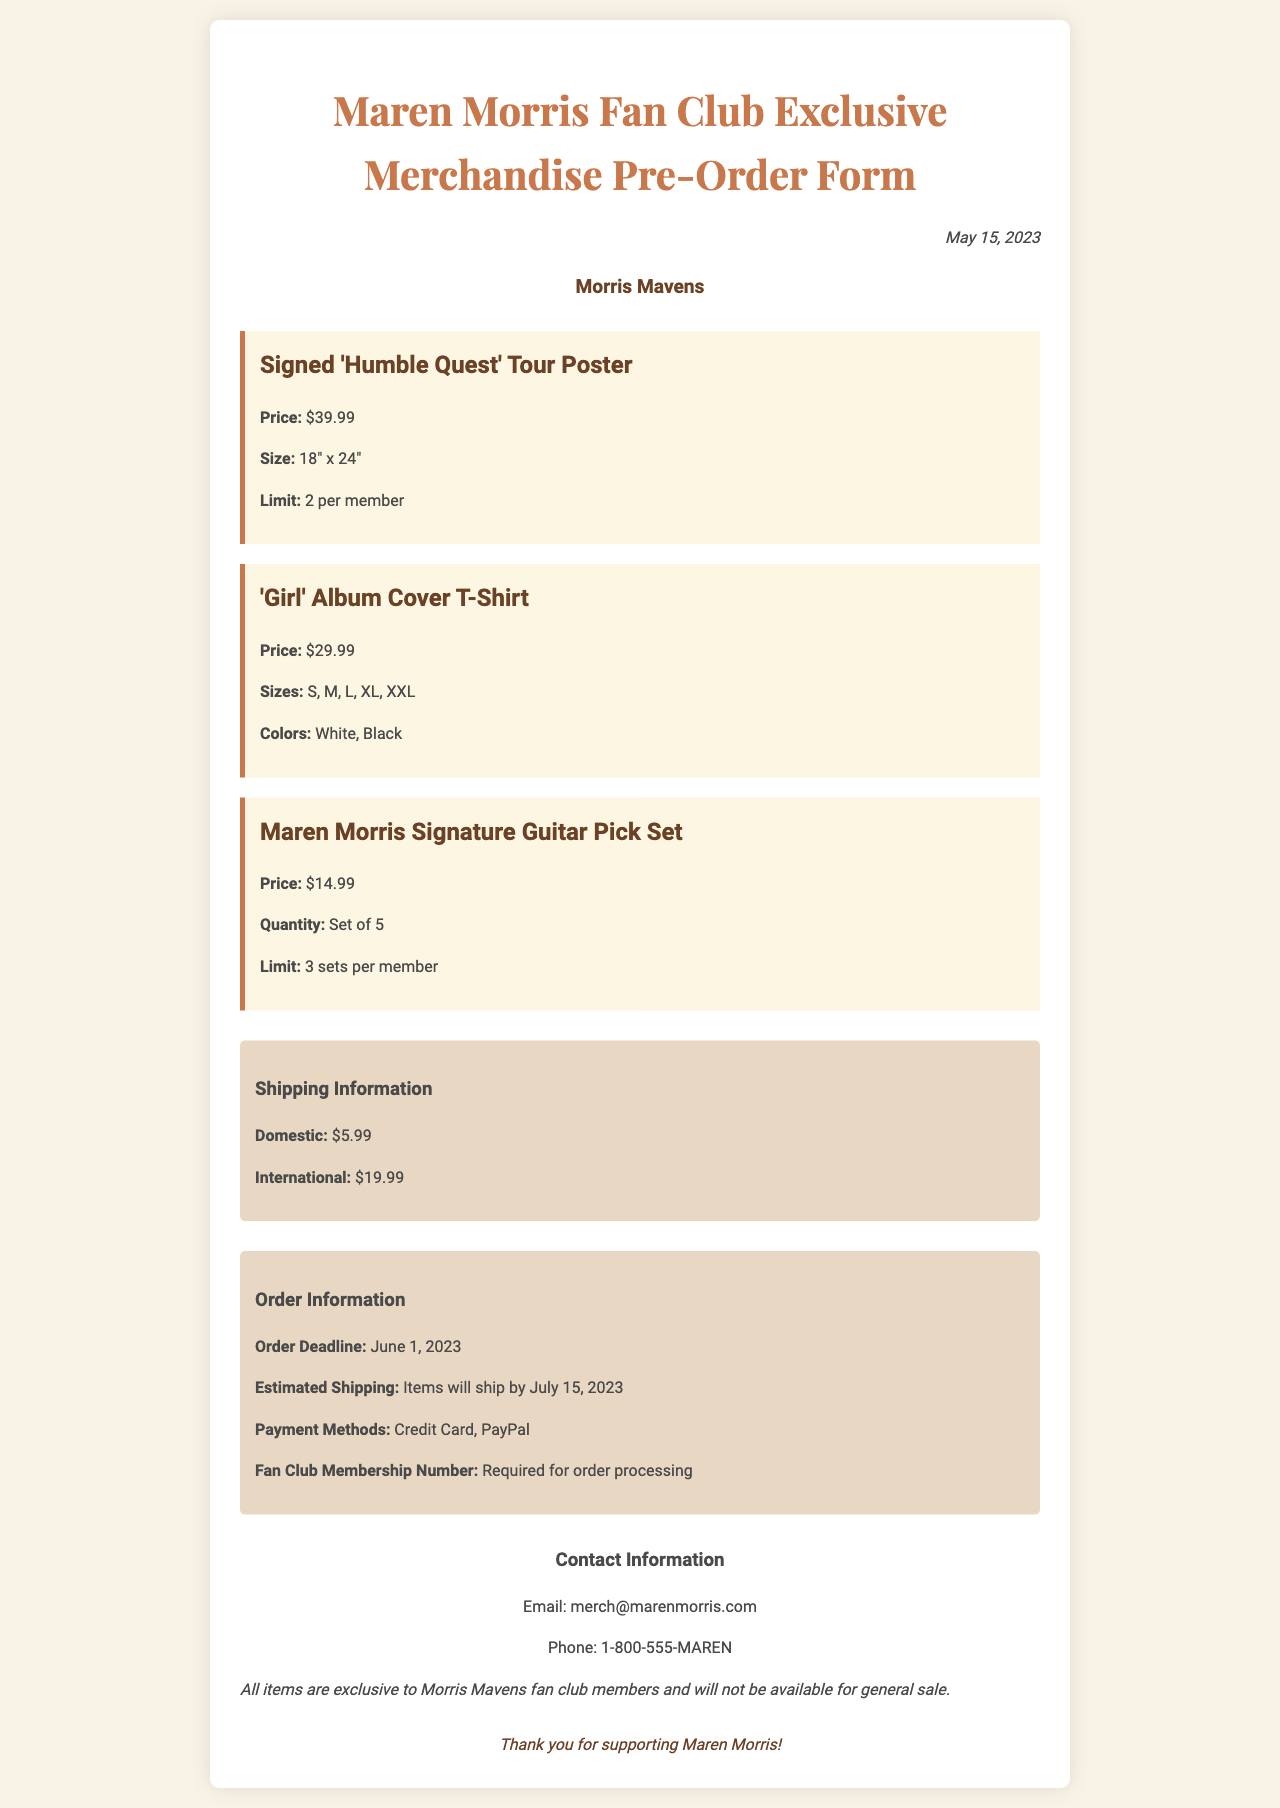What is the price of the signed tour poster? The price is explicitly listed under the item details for the signed poster.
Answer: $39.99 What is the order deadline? The order deadline is clearly mentioned in the order information section of the document.
Answer: June 1, 2023 How many sizes are available for the T-shirt? The number of sizes is specified in the item description for the T-shirt.
Answer: 5 What is the maximum quantity of guitar pick sets a member can order? The limit for ordering guitar pick sets is listed within the item description for the pick set.
Answer: 3 sets What is the shipping cost for international orders? The shipping costs are outlined in the shipping information section of the document.
Answer: $19.99 What methods of payment are accepted? The accepted payment methods are detailed in the order information.
Answer: Credit Card, PayPal What is needed for order processing? The requirement for order processing is also specified in the order information section.
Answer: Fan Club Membership Number What is the estimated shipping date for the items? The estimated shipping date is mentioned in the order information section.
Answer: July 15, 2023 What is the fan club name? The fan club name is displayed prominently at the top of the document.
Answer: Morris Mavens 